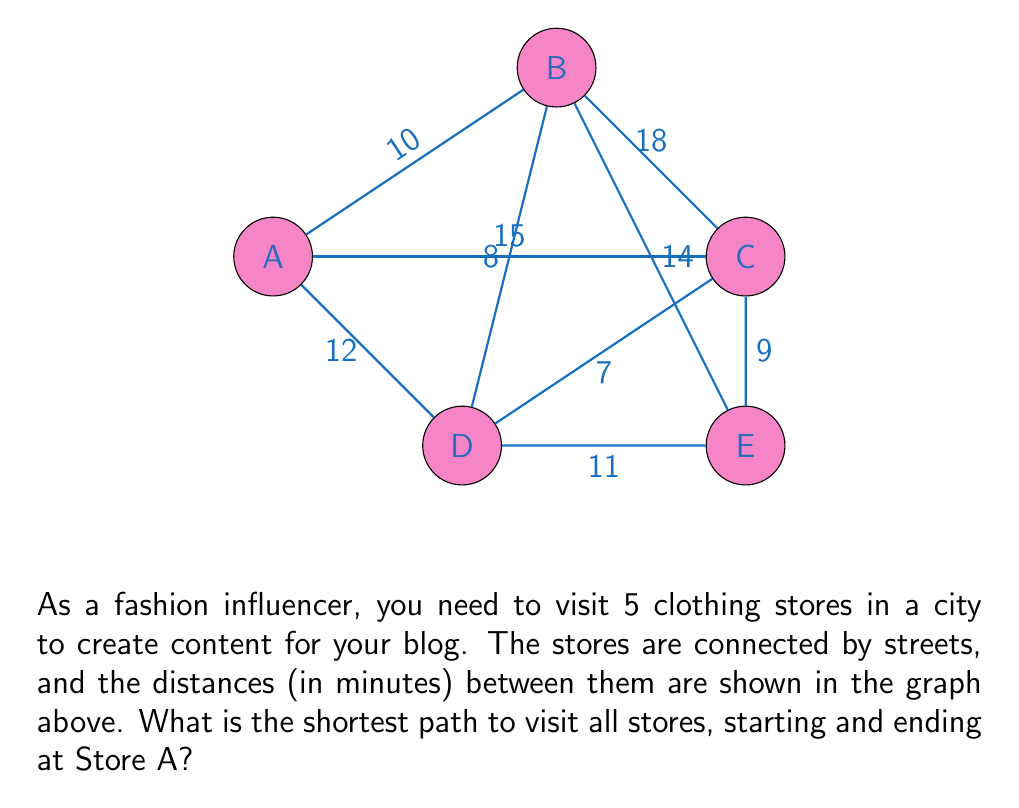What is the answer to this math problem? To solve this problem, we can use the Traveling Salesman Problem (TSP) approach. Since we have a small number of vertices, we can use a brute-force method to find the shortest path.

Step 1: List all possible paths starting and ending at Store A.
There are $(5-1)! = 24$ possible paths.

Step 2: Calculate the total distance for each path.
For example:
A-B-C-D-E-A = 10 + 18 + 7 + 11 + 15 = 61 minutes
A-B-C-E-D-A = 10 + 18 + 9 + 11 + 12 = 60 minutes
...

Step 3: Find the path with the minimum total distance.
After calculating all paths, we find that the shortest path is:
A-D-E-C-B-A with a total distance of 54 minutes.

Step 4: Verify the distance of the shortest path:
A to D: 12 minutes
D to E: 11 minutes
E to C: 9 minutes
C to B: 18 minutes
B to A: 10 minutes
Total: $12 + 11 + 9 + 18 + 10 = 54$ minutes

Therefore, the shortest path for the fashion influencer to visit all stores, starting and ending at Store A, is A-D-E-C-B-A with a total travel time of 54 minutes.
Answer: A-D-E-C-B-A, 54 minutes 